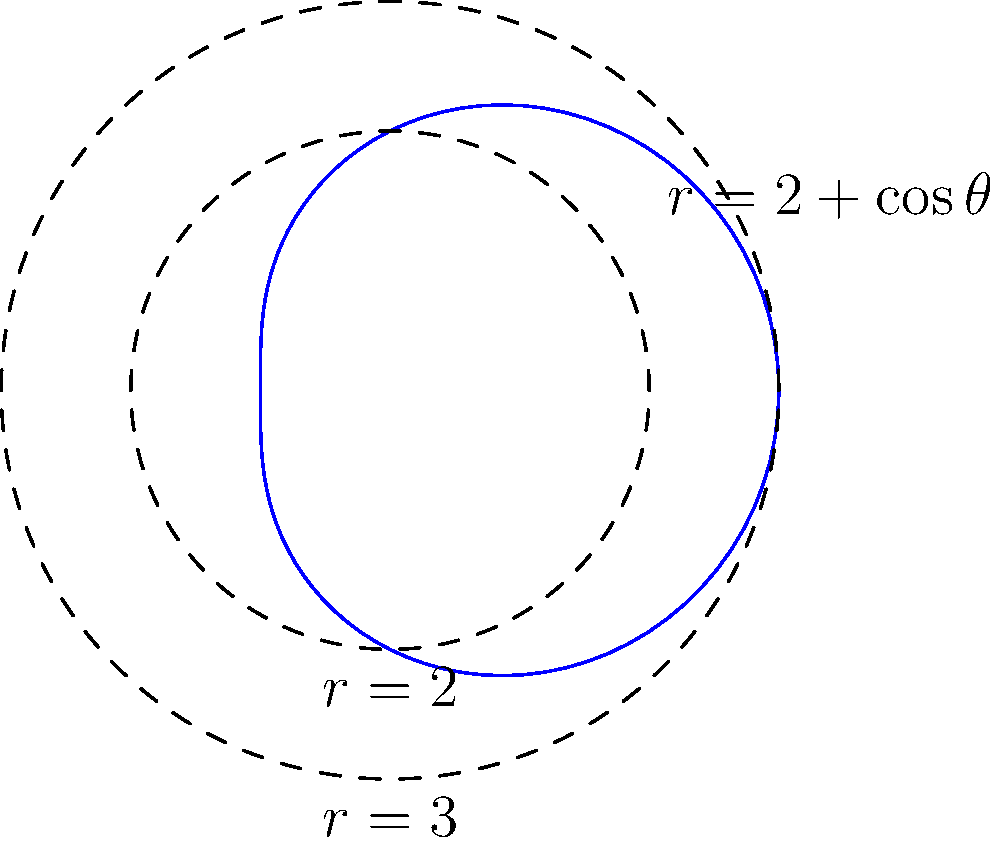In a circular crime scene, the boundary is described by the polar equation $r = 2 + \cos\theta$. Calculate the area of the region enclosed by this curve, given that it lies between two concentric circles with radii 2 and 3. Express your answer in terms of $\pi$. To solve this problem, we'll follow these steps:

1) The area of a region in polar coordinates is given by the formula:

   $$A = \frac{1}{2}\int_a^b [r(\theta)]^2 d\theta$$

2) In this case, $r(\theta) = 2 + \cos\theta$, and we need to integrate from 0 to $2\pi$:

   $$A = \frac{1}{2}\int_0^{2\pi} (2 + \cos\theta)^2 d\theta$$

3) Expand the integrand:

   $$(2 + \cos\theta)^2 = 4 + 4\cos\theta + \cos^2\theta$$

4) Therefore, our integral becomes:

   $$A = \frac{1}{2}\int_0^{2\pi} (4 + 4\cos\theta + \cos^2\theta) d\theta$$

5) Integrate each term:

   $$A = \frac{1}{2}[4\theta + 4\sin\theta + \frac{1}{2}\theta + \frac{1}{4}\sin(2\theta)]_0^{2\pi}$$

6) Evaluate the integral:

   $$A = \frac{1}{2}[(4 \cdot 2\pi + 0 + \frac{1}{2} \cdot 2\pi + 0) - (0 + 0 + 0 + 0)]$$

   $$A = \frac{1}{2}[8\pi + \pi] = \frac{9\pi}{2}$$

7) However, this is the area of the entire region enclosed by $r = 2 + \cos\theta$. We need to subtract the area of the inner circle and add the area of the outer circle:

   $$A_{final} = \frac{9\pi}{2} - \pi r_1^2 + \pi r_2^2$$
   $$A_{final} = \frac{9\pi}{2} - 4\pi + 9\pi = \frac{23\pi}{2}$$

Thus, the area of the region between the two circles is $\frac{23\pi}{2}$.
Answer: $\frac{23\pi}{2}$ 